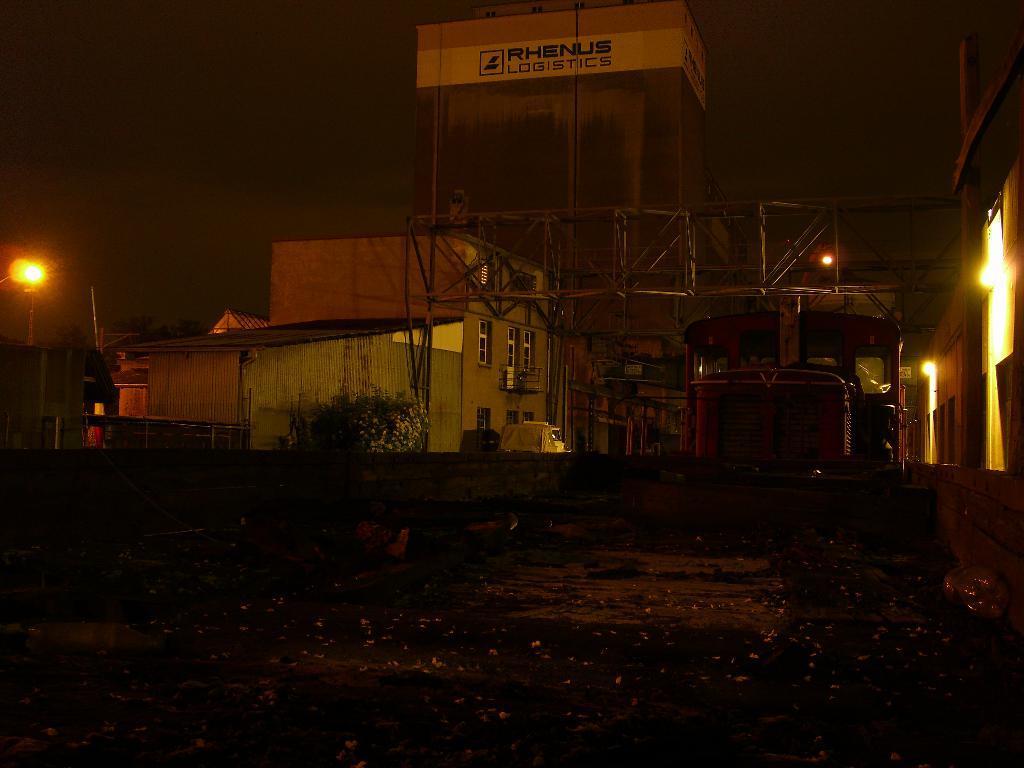Can you describe this image briefly? In this image we can see some dried leaves on the ground. We can also see a wall, some vehicles, a plant with some flowers, buildings, a metal frame, street lamps and a building with some text on it. 